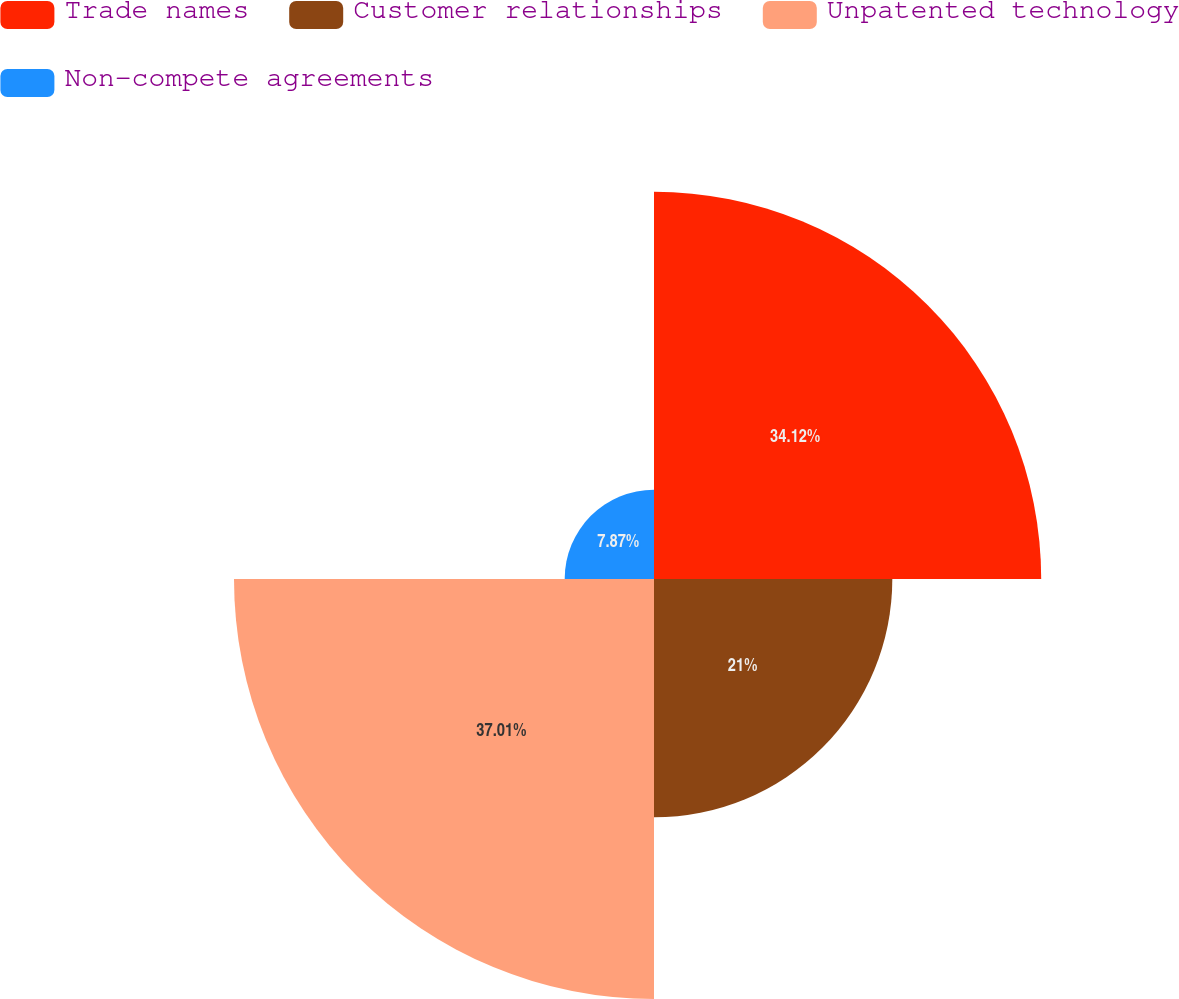Convert chart to OTSL. <chart><loc_0><loc_0><loc_500><loc_500><pie_chart><fcel>Trade names<fcel>Customer relationships<fcel>Unpatented technology<fcel>Non-compete agreements<nl><fcel>34.12%<fcel>21.0%<fcel>37.01%<fcel>7.87%<nl></chart> 